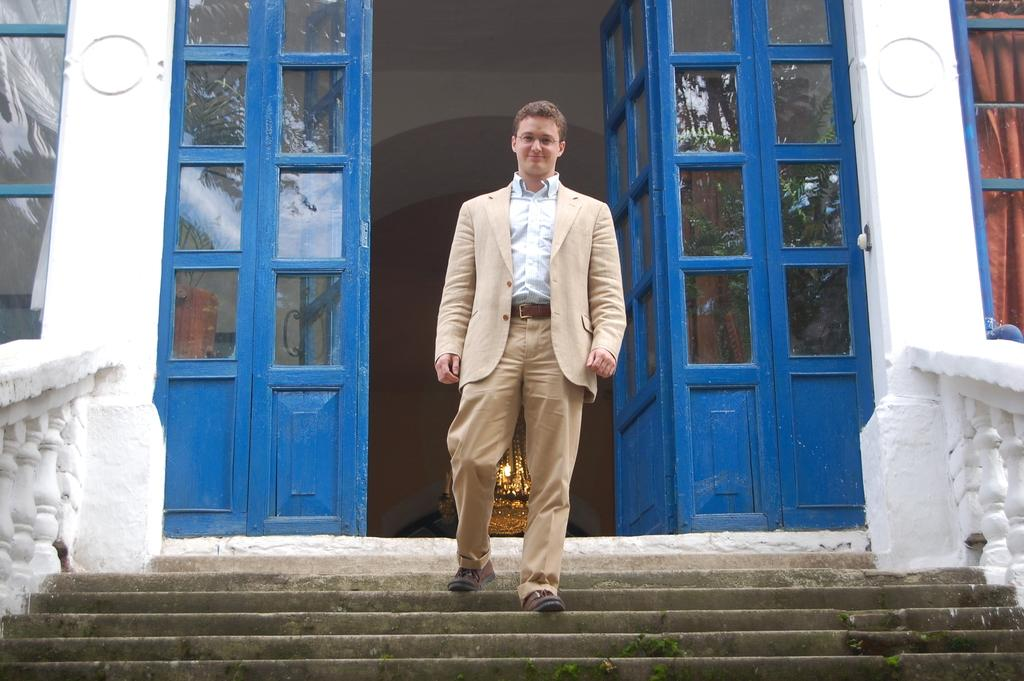Who is present in the image? There is a man in the image. What is the man doing in the image? The man is on the stairs. What can be seen in the background of the image? There are doors and windows in the background of the image. What type of zinc is visible on the stairs in the image? There is no zinc present in the image; it is a man standing on the stairs. Where is the spot where the man is standing in the image? The man is standing on the stairs, so there is no specific spot mentioned in the image. 